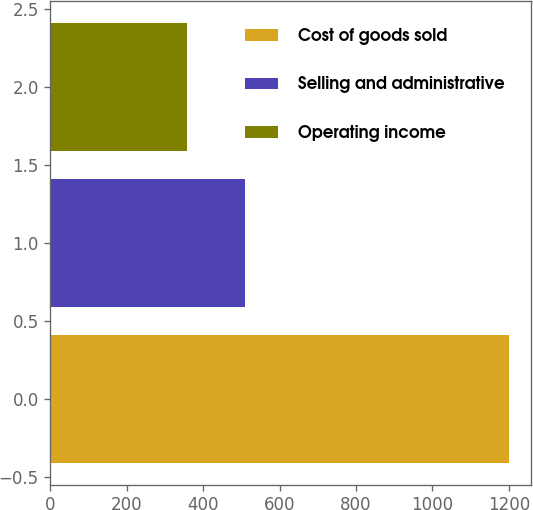Convert chart to OTSL. <chart><loc_0><loc_0><loc_500><loc_500><bar_chart><fcel>Cost of goods sold<fcel>Selling and administrative<fcel>Operating income<nl><fcel>1199<fcel>510.5<fcel>358.6<nl></chart> 